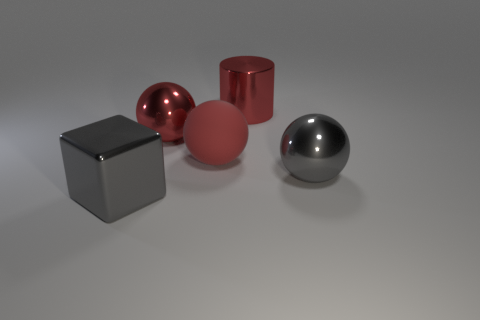There is another big red object that is the same shape as the matte object; what is it made of?
Provide a succinct answer. Metal. What is the color of the large metal object that is both to the right of the matte sphere and on the left side of the gray sphere?
Give a very brief answer. Red. What color is the big shiny block?
Provide a succinct answer. Gray. There is a ball that is the same color as the cube; what is its material?
Provide a succinct answer. Metal. Are there any other small red things that have the same shape as the red matte thing?
Offer a very short reply. No. There is a gray metal thing in front of the gray sphere; what is its size?
Provide a short and direct response. Large. There is a gray block that is the same size as the gray metallic ball; what material is it?
Your response must be concise. Metal. Is the number of tiny purple metallic spheres greater than the number of red rubber things?
Provide a short and direct response. No. There is a gray object behind the gray metallic thing that is in front of the big gray ball; how big is it?
Ensure brevity in your answer.  Large. What is the shape of the red metallic thing that is the same size as the red shiny cylinder?
Keep it short and to the point. Sphere. 